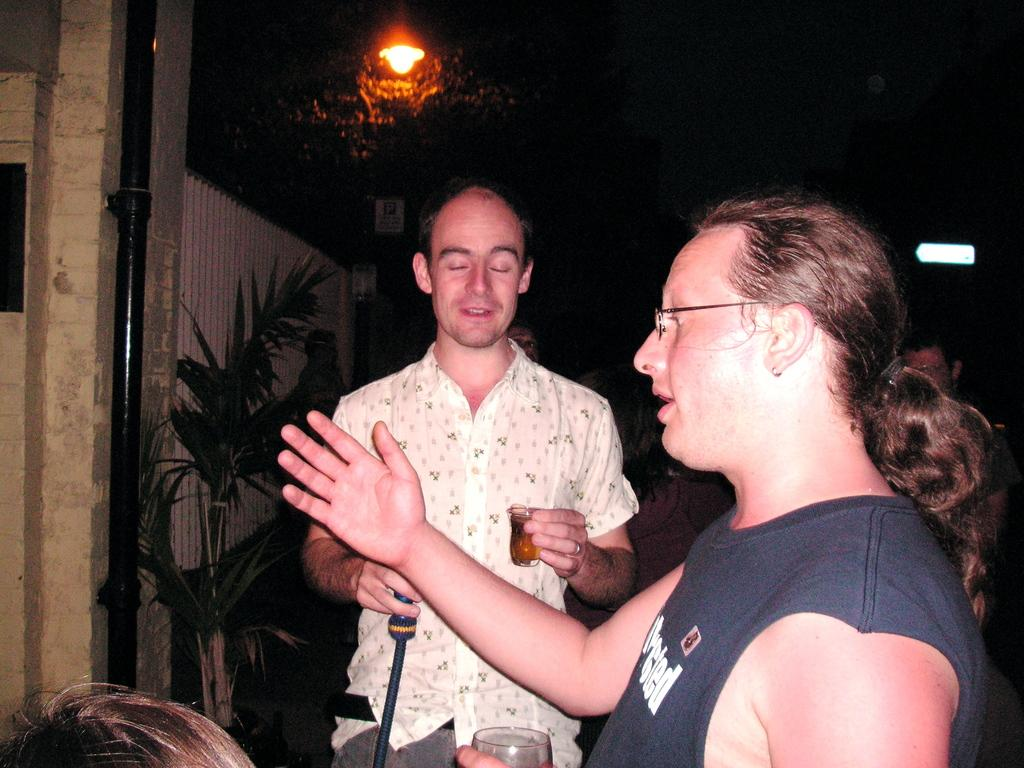How many people are in the image? There are two men in the image. What are the men holding in their hands? The men are holding glasses in their hands. What can be seen in the image besides the men and glasses? There is a plant and a wall in the image. What type of disease is the plant in the image suffering from? There is no indication in the image that the plant is suffering from any disease. 